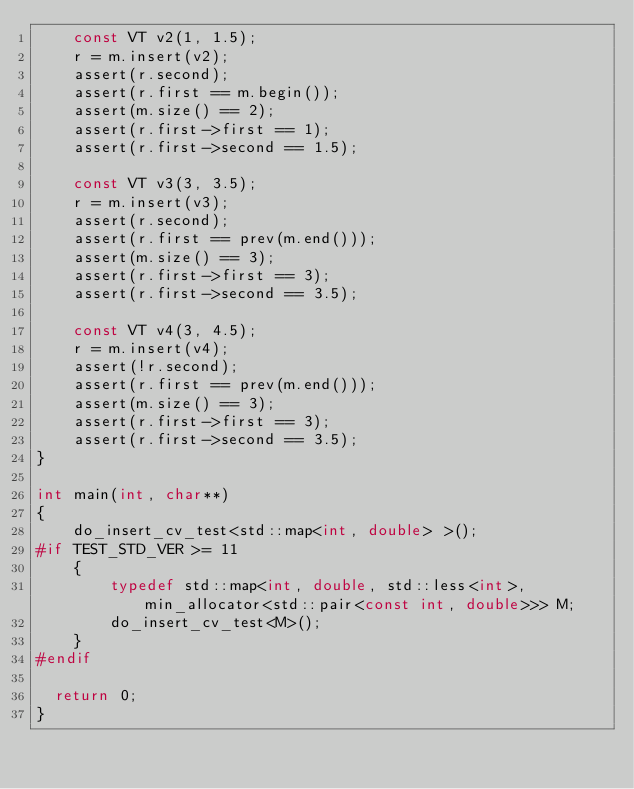<code> <loc_0><loc_0><loc_500><loc_500><_C++_>    const VT v2(1, 1.5);
    r = m.insert(v2);
    assert(r.second);
    assert(r.first == m.begin());
    assert(m.size() == 2);
    assert(r.first->first == 1);
    assert(r.first->second == 1.5);

    const VT v3(3, 3.5);
    r = m.insert(v3);
    assert(r.second);
    assert(r.first == prev(m.end()));
    assert(m.size() == 3);
    assert(r.first->first == 3);
    assert(r.first->second == 3.5);

    const VT v4(3, 4.5);
    r = m.insert(v4);
    assert(!r.second);
    assert(r.first == prev(m.end()));
    assert(m.size() == 3);
    assert(r.first->first == 3);
    assert(r.first->second == 3.5);
}

int main(int, char**)
{
    do_insert_cv_test<std::map<int, double> >();
#if TEST_STD_VER >= 11
    {
        typedef std::map<int, double, std::less<int>, min_allocator<std::pair<const int, double>>> M;
        do_insert_cv_test<M>();
    }
#endif

  return 0;
}
</code> 